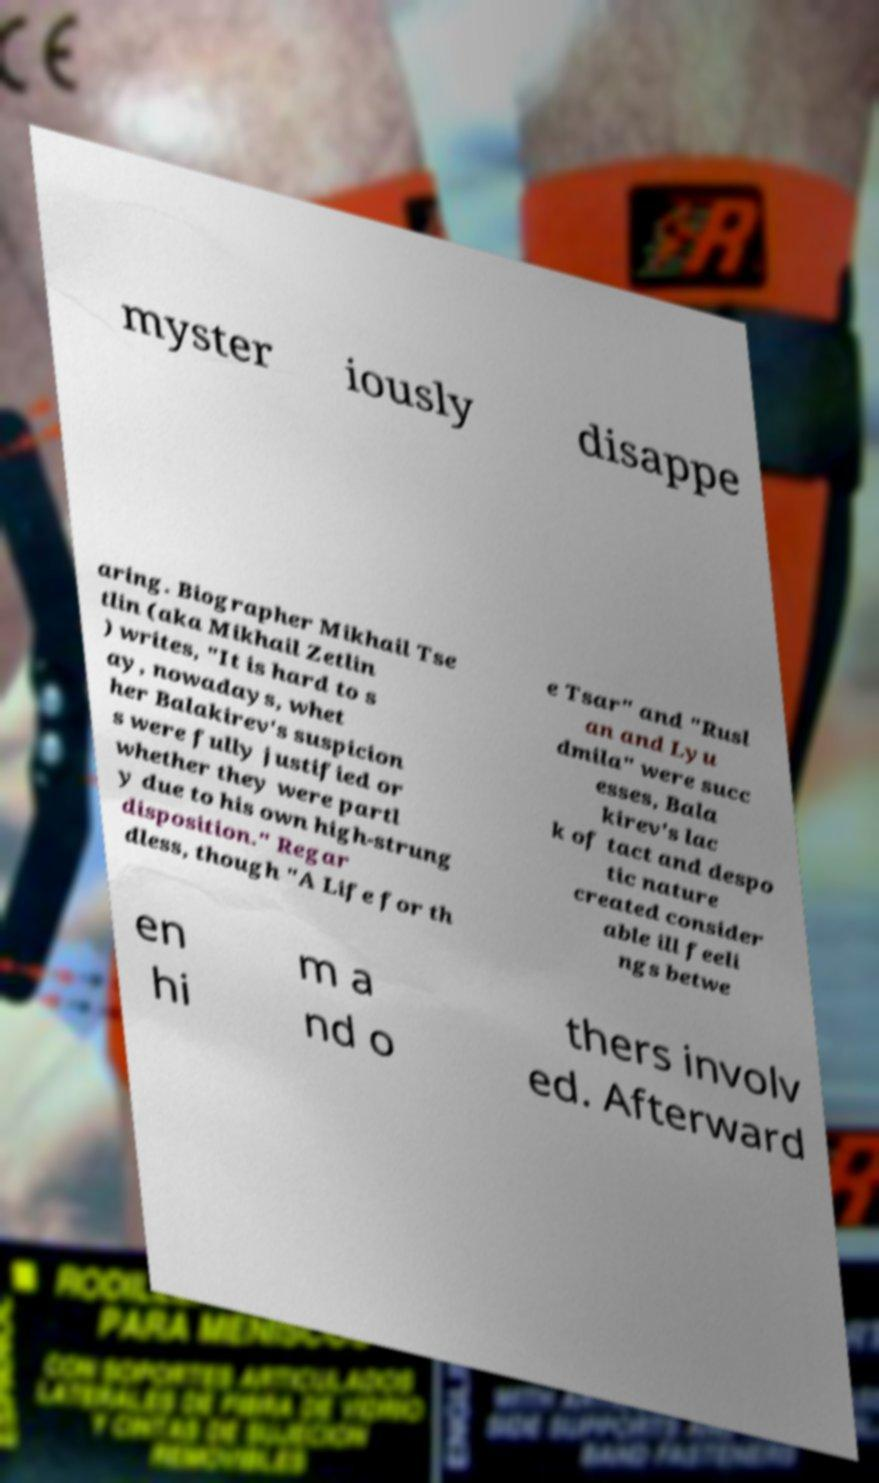Could you assist in decoding the text presented in this image and type it out clearly? myster iously disappe aring. Biographer Mikhail Tse tlin (aka Mikhail Zetlin ) writes, "It is hard to s ay, nowadays, whet her Balakirev's suspicion s were fully justified or whether they were partl y due to his own high-strung disposition." Regar dless, though "A Life for th e Tsar" and "Rusl an and Lyu dmila" were succ esses, Bala kirev's lac k of tact and despo tic nature created consider able ill feeli ngs betwe en hi m a nd o thers involv ed. Afterward 